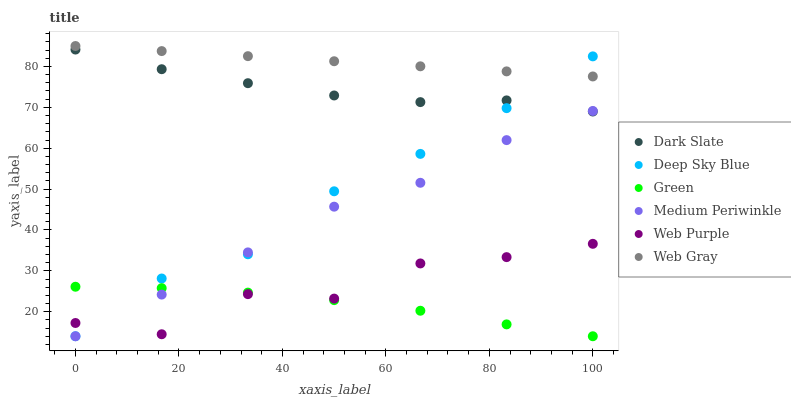Does Green have the minimum area under the curve?
Answer yes or no. Yes. Does Web Gray have the maximum area under the curve?
Answer yes or no. Yes. Does Medium Periwinkle have the minimum area under the curve?
Answer yes or no. No. Does Medium Periwinkle have the maximum area under the curve?
Answer yes or no. No. Is Web Gray the smoothest?
Answer yes or no. Yes. Is Web Purple the roughest?
Answer yes or no. Yes. Is Medium Periwinkle the smoothest?
Answer yes or no. No. Is Medium Periwinkle the roughest?
Answer yes or no. No. Does Medium Periwinkle have the lowest value?
Answer yes or no. Yes. Does Dark Slate have the lowest value?
Answer yes or no. No. Does Web Gray have the highest value?
Answer yes or no. Yes. Does Medium Periwinkle have the highest value?
Answer yes or no. No. Is Web Purple less than Web Gray?
Answer yes or no. Yes. Is Web Gray greater than Dark Slate?
Answer yes or no. Yes. Does Web Gray intersect Deep Sky Blue?
Answer yes or no. Yes. Is Web Gray less than Deep Sky Blue?
Answer yes or no. No. Is Web Gray greater than Deep Sky Blue?
Answer yes or no. No. Does Web Purple intersect Web Gray?
Answer yes or no. No. 